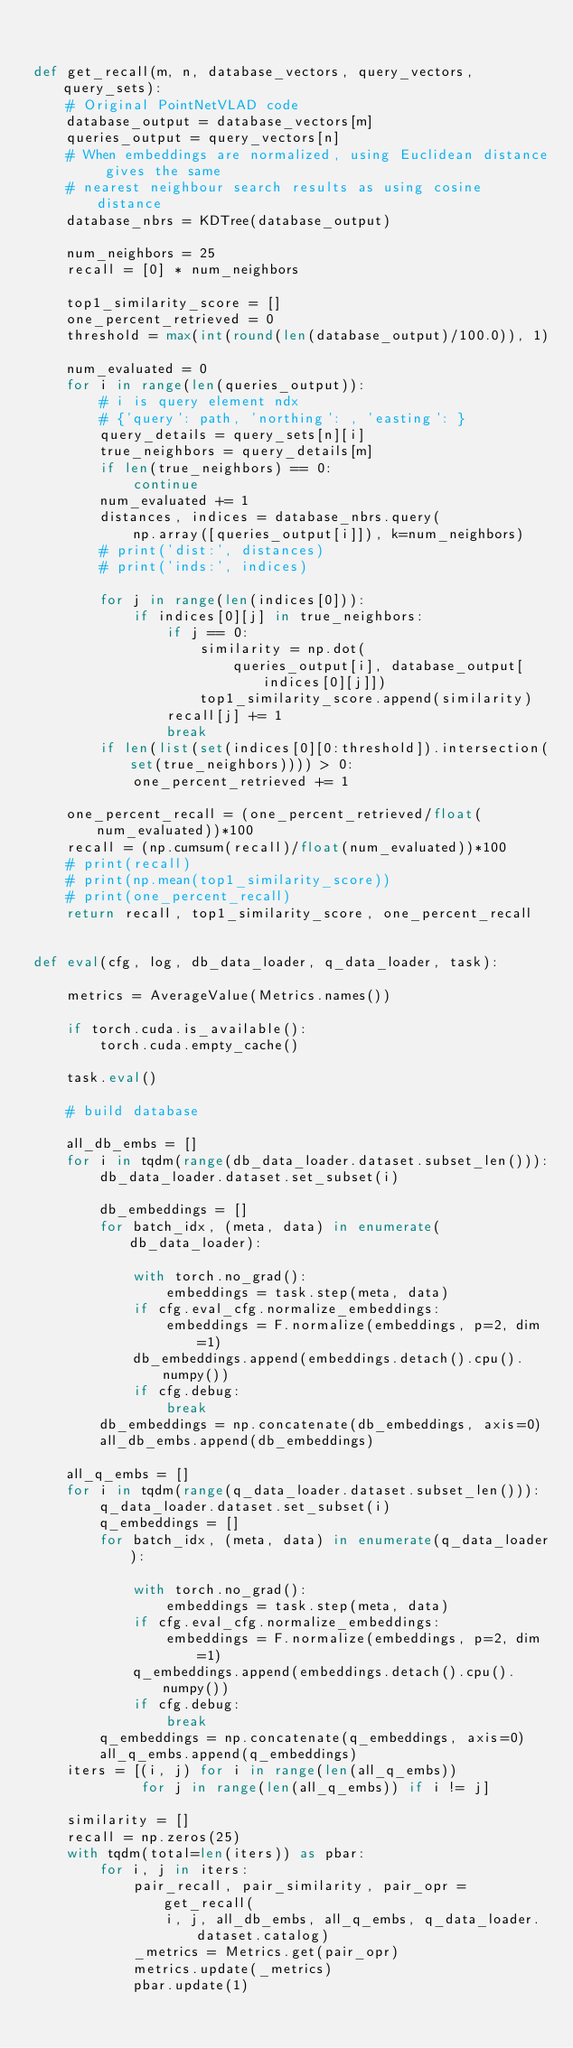Convert code to text. <code><loc_0><loc_0><loc_500><loc_500><_Python_>

def get_recall(m, n, database_vectors, query_vectors, query_sets):
    # Original PointNetVLAD code
    database_output = database_vectors[m]
    queries_output = query_vectors[n]
    # When embeddings are normalized, using Euclidean distance gives the same
    # nearest neighbour search results as using cosine distance
    database_nbrs = KDTree(database_output)

    num_neighbors = 25
    recall = [0] * num_neighbors

    top1_similarity_score = []
    one_percent_retrieved = 0
    threshold = max(int(round(len(database_output)/100.0)), 1)

    num_evaluated = 0
    for i in range(len(queries_output)):
        # i is query element ndx
        # {'query': path, 'northing': , 'easting': }
        query_details = query_sets[n][i]
        true_neighbors = query_details[m]
        if len(true_neighbors) == 0:
            continue
        num_evaluated += 1
        distances, indices = database_nbrs.query(
            np.array([queries_output[i]]), k=num_neighbors)
        # print('dist:', distances)
        # print('inds:', indices)

        for j in range(len(indices[0])):
            if indices[0][j] in true_neighbors:
                if j == 0:
                    similarity = np.dot(
                        queries_output[i], database_output[indices[0][j]])
                    top1_similarity_score.append(similarity)
                recall[j] += 1
                break
        if len(list(set(indices[0][0:threshold]).intersection(set(true_neighbors)))) > 0:
            one_percent_retrieved += 1

    one_percent_recall = (one_percent_retrieved/float(num_evaluated))*100
    recall = (np.cumsum(recall)/float(num_evaluated))*100
    # print(recall)
    # print(np.mean(top1_similarity_score))
    # print(one_percent_recall)
    return recall, top1_similarity_score, one_percent_recall


def eval(cfg, log, db_data_loader, q_data_loader, task):

    metrics = AverageValue(Metrics.names())

    if torch.cuda.is_available():
        torch.cuda.empty_cache()

    task.eval()

    # build database

    all_db_embs = []
    for i in tqdm(range(db_data_loader.dataset.subset_len())):
        db_data_loader.dataset.set_subset(i)

        db_embeddings = []
        for batch_idx, (meta, data) in enumerate(db_data_loader):

            with torch.no_grad():
                embeddings = task.step(meta, data)
            if cfg.eval_cfg.normalize_embeddings:
                embeddings = F.normalize(embeddings, p=2, dim=1)
            db_embeddings.append(embeddings.detach().cpu().numpy())
            if cfg.debug:
                break
        db_embeddings = np.concatenate(db_embeddings, axis=0)
        all_db_embs.append(db_embeddings)

    all_q_embs = []
    for i in tqdm(range(q_data_loader.dataset.subset_len())):
        q_data_loader.dataset.set_subset(i)
        q_embeddings = []
        for batch_idx, (meta, data) in enumerate(q_data_loader):

            with torch.no_grad():
                embeddings = task.step(meta, data)
            if cfg.eval_cfg.normalize_embeddings:
                embeddings = F.normalize(embeddings, p=2, dim=1)
            q_embeddings.append(embeddings.detach().cpu().numpy())
            if cfg.debug:
                break
        q_embeddings = np.concatenate(q_embeddings, axis=0)
        all_q_embs.append(q_embeddings)
    iters = [(i, j) for i in range(len(all_q_embs))
             for j in range(len(all_q_embs)) if i != j]

    similarity = []
    recall = np.zeros(25)
    with tqdm(total=len(iters)) as pbar:
        for i, j in iters:
            pair_recall, pair_similarity, pair_opr = get_recall(
                i, j, all_db_embs, all_q_embs, q_data_loader.dataset.catalog)
            _metrics = Metrics.get(pair_opr)
            metrics.update(_metrics)
            pbar.update(1)</code> 